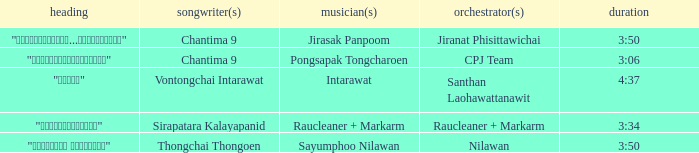Who was the composer of "ขอโทษ"? Intarawat. 